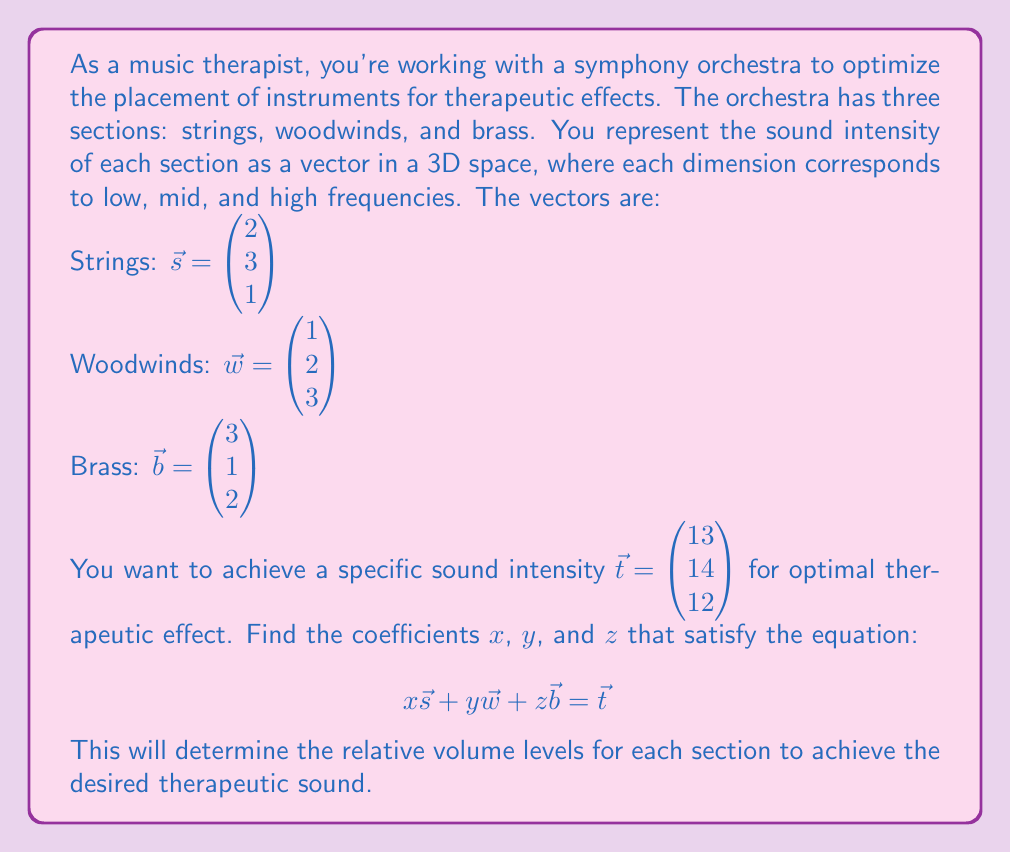Solve this math problem. To solve this problem, we need to set up a system of linear equations and solve for the coefficients $x$, $y$, and $z$. Let's break it down step by step:

1) First, let's write out the equation in component form:

   $$\begin{pmatrix} 2x + y + 3z \\ 3x + 2y + z \\ x + 3y + 2z \end{pmatrix} = \begin{pmatrix} 13 \\ 14 \\ 12 \end{pmatrix}$$

2) This gives us three equations:
   
   $2x + y + 3z = 13$
   $3x + 2y + z = 14$
   $x + 3y + 2z = 12$

3) We can solve this system using elimination or substitution. Let's use elimination:

4) Multiply the first equation by 3 and the second by -2:

   $6x + 3y + 9z = 39$
   $-6x - 4y - 2z = -28$

5) Add these equations:

   $-y + 7z = 11$

6) Now multiply the original first equation by 3 and the third by -2:

   $6x + 3y + 9z = 39$
   $-2x - 6y - 4z = -24$

7) Add these equations:

   $4x - 3y + 5z = 15$

8) We now have three equations:

   $2x + y + 3z = 13$
   $-y + 7z = 11$
   $4x - 3y + 5z = 15$

9) From the second equation:
   
   $y = 7z - 11$

10) Substitute this into the first equation:

    $2x + (7z - 11) + 3z = 13$
    $2x + 10z = 24$
    $x = 12 - 5z$

11) Substitute both of these into the third equation:

    $4(12 - 5z) - 3(7z - 11) + 5z = 15$
    $48 - 20z - 21z + 33 + 5z = 15$
    $81 - 36z = 15$
    $-36z = -66$
    $z = \frac{11}{6}$

12) Now we can find $x$ and $y$:

    $x = 12 - 5(\frac{11}{6}) = 12 - \frac{55}{6} = \frac{17}{6}$
    $y = 7(\frac{11}{6}) - 11 = \frac{77}{6} - 11 = \frac{11}{6}$

Therefore, the solution is $x = \frac{17}{6}$, $y = \frac{11}{6}$, and $z = \frac{11}{6}$.
Answer: $x = \frac{17}{6}$, $y = \frac{11}{6}$, $z = \frac{11}{6}$ 